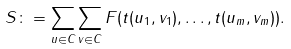<formula> <loc_0><loc_0><loc_500><loc_500>S \colon = \sum _ { u \in C } \sum _ { v \in C } F ( t ( u _ { 1 } , v _ { 1 } ) , \dots , t ( u _ { m } , v _ { m } ) ) .</formula> 